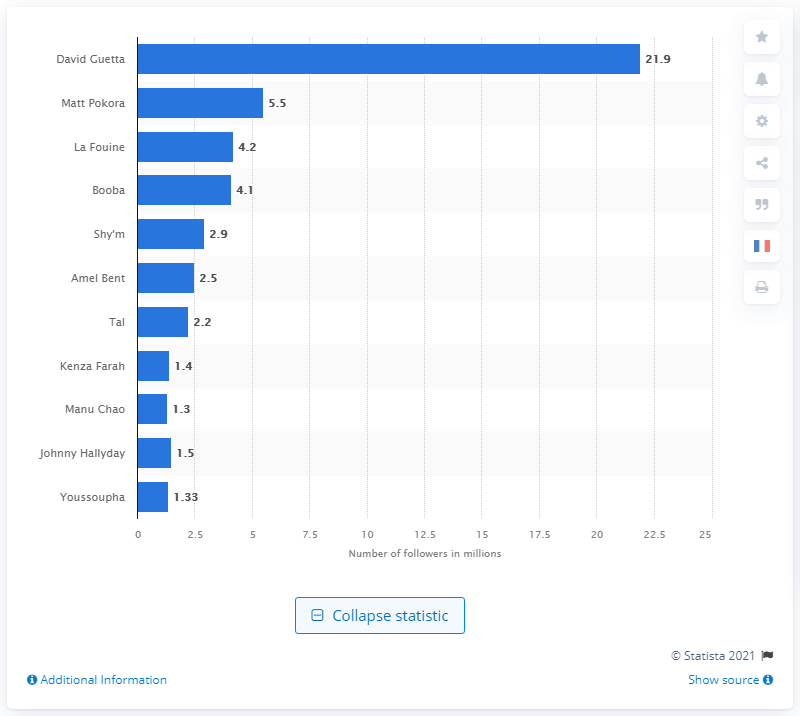Point out several critical features in this image. David Guetta, who overheard the personalities of music with its international notoriety, is renowned for his exceptional talent in the music industry. Matt Pokora was the most followed singer on Twitter. 